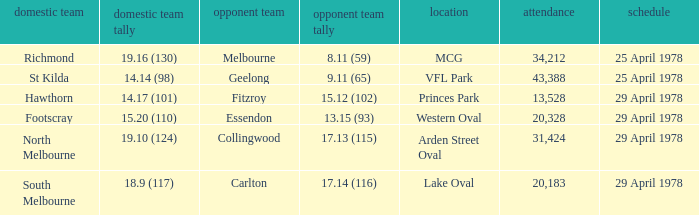What was the away team that played at Princes Park? Fitzroy. 